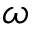Convert formula to latex. <formula><loc_0><loc_0><loc_500><loc_500>\omega</formula> 